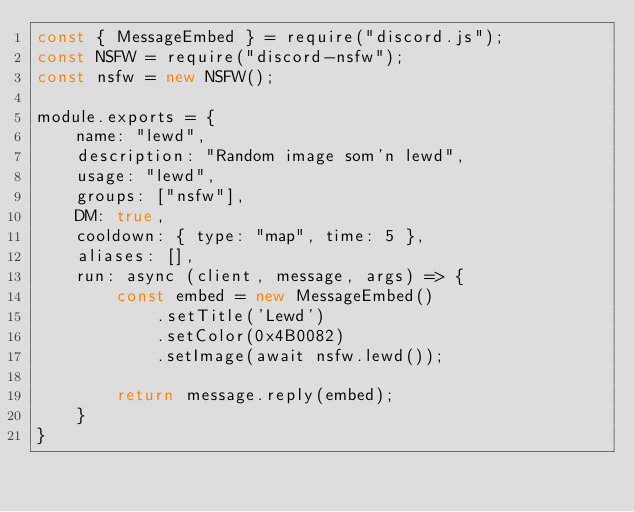<code> <loc_0><loc_0><loc_500><loc_500><_JavaScript_>const { MessageEmbed } = require("discord.js");
const NSFW = require("discord-nsfw");
const nsfw = new NSFW();

module.exports = {
    name: "lewd",
    description: "Random image som'n lewd",
    usage: "lewd",
    groups: ["nsfw"],
    DM: true,
    cooldown: { type: "map", time: 5 },
    aliases: [],
    run: async (client, message, args) => {
        const embed = new MessageEmbed()
            .setTitle('Lewd')
            .setColor(0x4B0082)
            .setImage(await nsfw.lewd());

        return message.reply(embed);
    }
}</code> 